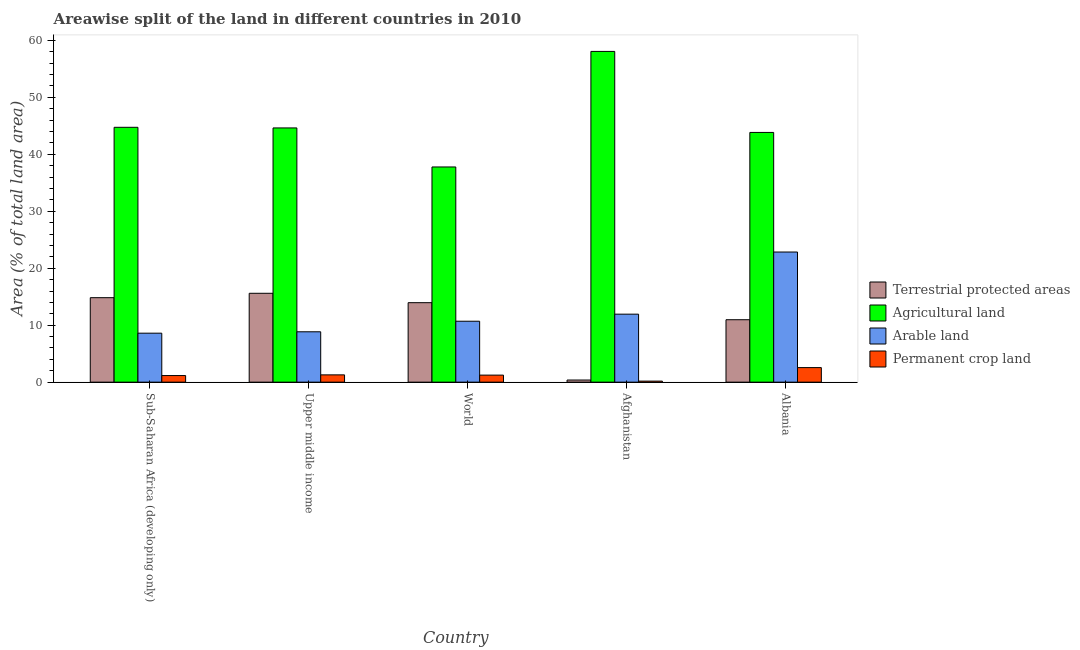How many different coloured bars are there?
Make the answer very short. 4. How many groups of bars are there?
Keep it short and to the point. 5. Are the number of bars on each tick of the X-axis equal?
Provide a succinct answer. Yes. How many bars are there on the 3rd tick from the left?
Provide a succinct answer. 4. What is the label of the 2nd group of bars from the left?
Provide a short and direct response. Upper middle income. In how many cases, is the number of bars for a given country not equal to the number of legend labels?
Provide a succinct answer. 0. What is the percentage of area under permanent crop land in World?
Offer a terse response. 1.23. Across all countries, what is the maximum percentage of area under agricultural land?
Give a very brief answer. 58.07. Across all countries, what is the minimum percentage of area under permanent crop land?
Your response must be concise. 0.18. In which country was the percentage of land under terrestrial protection maximum?
Your response must be concise. Upper middle income. In which country was the percentage of land under terrestrial protection minimum?
Offer a very short reply. Afghanistan. What is the total percentage of land under terrestrial protection in the graph?
Ensure brevity in your answer.  55.71. What is the difference between the percentage of land under terrestrial protection in Upper middle income and that in World?
Your answer should be very brief. 1.65. What is the difference between the percentage of area under permanent crop land in Sub-Saharan Africa (developing only) and the percentage of land under terrestrial protection in World?
Offer a terse response. -12.79. What is the average percentage of area under arable land per country?
Offer a terse response. 12.58. What is the difference between the percentage of area under permanent crop land and percentage of land under terrestrial protection in Afghanistan?
Keep it short and to the point. -0.19. What is the ratio of the percentage of area under arable land in Afghanistan to that in Upper middle income?
Make the answer very short. 1.35. What is the difference between the highest and the second highest percentage of land under terrestrial protection?
Make the answer very short. 0.77. What is the difference between the highest and the lowest percentage of land under terrestrial protection?
Offer a very short reply. 15.23. In how many countries, is the percentage of area under permanent crop land greater than the average percentage of area under permanent crop land taken over all countries?
Your answer should be very brief. 1. Is it the case that in every country, the sum of the percentage of area under permanent crop land and percentage of area under arable land is greater than the sum of percentage of area under agricultural land and percentage of land under terrestrial protection?
Make the answer very short. Yes. What does the 1st bar from the left in Afghanistan represents?
Provide a short and direct response. Terrestrial protected areas. What does the 4th bar from the right in Upper middle income represents?
Provide a short and direct response. Terrestrial protected areas. Is it the case that in every country, the sum of the percentage of land under terrestrial protection and percentage of area under agricultural land is greater than the percentage of area under arable land?
Provide a short and direct response. Yes. How many bars are there?
Ensure brevity in your answer.  20. How many countries are there in the graph?
Keep it short and to the point. 5. What is the difference between two consecutive major ticks on the Y-axis?
Provide a succinct answer. 10. Are the values on the major ticks of Y-axis written in scientific E-notation?
Provide a succinct answer. No. Does the graph contain grids?
Provide a short and direct response. No. How many legend labels are there?
Ensure brevity in your answer.  4. How are the legend labels stacked?
Ensure brevity in your answer.  Vertical. What is the title of the graph?
Provide a short and direct response. Areawise split of the land in different countries in 2010. What is the label or title of the X-axis?
Make the answer very short. Country. What is the label or title of the Y-axis?
Your answer should be very brief. Area (% of total land area). What is the Area (% of total land area) of Terrestrial protected areas in Sub-Saharan Africa (developing only)?
Make the answer very short. 14.83. What is the Area (% of total land area) in Agricultural land in Sub-Saharan Africa (developing only)?
Offer a very short reply. 44.74. What is the Area (% of total land area) of Arable land in Sub-Saharan Africa (developing only)?
Keep it short and to the point. 8.6. What is the Area (% of total land area) in Permanent crop land in Sub-Saharan Africa (developing only)?
Make the answer very short. 1.16. What is the Area (% of total land area) in Terrestrial protected areas in Upper middle income?
Provide a short and direct response. 15.6. What is the Area (% of total land area) in Agricultural land in Upper middle income?
Provide a short and direct response. 44.63. What is the Area (% of total land area) of Arable land in Upper middle income?
Your answer should be very brief. 8.84. What is the Area (% of total land area) in Permanent crop land in Upper middle income?
Ensure brevity in your answer.  1.28. What is the Area (% of total land area) of Terrestrial protected areas in World?
Ensure brevity in your answer.  13.95. What is the Area (% of total land area) of Agricultural land in World?
Your answer should be compact. 37.78. What is the Area (% of total land area) in Arable land in World?
Make the answer very short. 10.7. What is the Area (% of total land area) in Permanent crop land in World?
Ensure brevity in your answer.  1.23. What is the Area (% of total land area) in Terrestrial protected areas in Afghanistan?
Your answer should be very brief. 0.37. What is the Area (% of total land area) in Agricultural land in Afghanistan?
Offer a very short reply. 58.07. What is the Area (% of total land area) in Arable land in Afghanistan?
Make the answer very short. 11.94. What is the Area (% of total land area) in Permanent crop land in Afghanistan?
Your response must be concise. 0.18. What is the Area (% of total land area) of Terrestrial protected areas in Albania?
Your answer should be compact. 10.96. What is the Area (% of total land area) in Agricultural land in Albania?
Make the answer very short. 43.84. What is the Area (% of total land area) in Arable land in Albania?
Keep it short and to the point. 22.85. What is the Area (% of total land area) in Permanent crop land in Albania?
Ensure brevity in your answer.  2.55. Across all countries, what is the maximum Area (% of total land area) in Terrestrial protected areas?
Your answer should be compact. 15.6. Across all countries, what is the maximum Area (% of total land area) in Agricultural land?
Your answer should be compact. 58.07. Across all countries, what is the maximum Area (% of total land area) of Arable land?
Ensure brevity in your answer.  22.85. Across all countries, what is the maximum Area (% of total land area) of Permanent crop land?
Offer a terse response. 2.55. Across all countries, what is the minimum Area (% of total land area) of Terrestrial protected areas?
Offer a terse response. 0.37. Across all countries, what is the minimum Area (% of total land area) of Agricultural land?
Keep it short and to the point. 37.78. Across all countries, what is the minimum Area (% of total land area) in Arable land?
Give a very brief answer. 8.6. Across all countries, what is the minimum Area (% of total land area) of Permanent crop land?
Your answer should be compact. 0.18. What is the total Area (% of total land area) in Terrestrial protected areas in the graph?
Offer a very short reply. 55.71. What is the total Area (% of total land area) of Agricultural land in the graph?
Your response must be concise. 229.07. What is the total Area (% of total land area) of Arable land in the graph?
Your answer should be compact. 62.92. What is the total Area (% of total land area) of Permanent crop land in the graph?
Make the answer very short. 6.4. What is the difference between the Area (% of total land area) in Terrestrial protected areas in Sub-Saharan Africa (developing only) and that in Upper middle income?
Your answer should be very brief. -0.77. What is the difference between the Area (% of total land area) of Agricultural land in Sub-Saharan Africa (developing only) and that in Upper middle income?
Ensure brevity in your answer.  0.11. What is the difference between the Area (% of total land area) in Arable land in Sub-Saharan Africa (developing only) and that in Upper middle income?
Your answer should be very brief. -0.24. What is the difference between the Area (% of total land area) in Permanent crop land in Sub-Saharan Africa (developing only) and that in Upper middle income?
Give a very brief answer. -0.12. What is the difference between the Area (% of total land area) of Terrestrial protected areas in Sub-Saharan Africa (developing only) and that in World?
Give a very brief answer. 0.88. What is the difference between the Area (% of total land area) of Agricultural land in Sub-Saharan Africa (developing only) and that in World?
Keep it short and to the point. 6.96. What is the difference between the Area (% of total land area) of Arable land in Sub-Saharan Africa (developing only) and that in World?
Your answer should be compact. -2.1. What is the difference between the Area (% of total land area) in Permanent crop land in Sub-Saharan Africa (developing only) and that in World?
Your answer should be very brief. -0.08. What is the difference between the Area (% of total land area) in Terrestrial protected areas in Sub-Saharan Africa (developing only) and that in Afghanistan?
Keep it short and to the point. 14.46. What is the difference between the Area (% of total land area) in Agricultural land in Sub-Saharan Africa (developing only) and that in Afghanistan?
Give a very brief answer. -13.33. What is the difference between the Area (% of total land area) in Arable land in Sub-Saharan Africa (developing only) and that in Afghanistan?
Your answer should be compact. -3.34. What is the difference between the Area (% of total land area) in Permanent crop land in Sub-Saharan Africa (developing only) and that in Afghanistan?
Your answer should be compact. 0.98. What is the difference between the Area (% of total land area) of Terrestrial protected areas in Sub-Saharan Africa (developing only) and that in Albania?
Ensure brevity in your answer.  3.87. What is the difference between the Area (% of total land area) of Agricultural land in Sub-Saharan Africa (developing only) and that in Albania?
Make the answer very short. 0.9. What is the difference between the Area (% of total land area) of Arable land in Sub-Saharan Africa (developing only) and that in Albania?
Provide a short and direct response. -14.25. What is the difference between the Area (% of total land area) of Permanent crop land in Sub-Saharan Africa (developing only) and that in Albania?
Provide a succinct answer. -1.4. What is the difference between the Area (% of total land area) in Terrestrial protected areas in Upper middle income and that in World?
Your response must be concise. 1.65. What is the difference between the Area (% of total land area) in Agricultural land in Upper middle income and that in World?
Ensure brevity in your answer.  6.85. What is the difference between the Area (% of total land area) of Arable land in Upper middle income and that in World?
Give a very brief answer. -1.86. What is the difference between the Area (% of total land area) in Permanent crop land in Upper middle income and that in World?
Ensure brevity in your answer.  0.04. What is the difference between the Area (% of total land area) in Terrestrial protected areas in Upper middle income and that in Afghanistan?
Your answer should be very brief. 15.23. What is the difference between the Area (% of total land area) in Agricultural land in Upper middle income and that in Afghanistan?
Keep it short and to the point. -13.43. What is the difference between the Area (% of total land area) of Arable land in Upper middle income and that in Afghanistan?
Your response must be concise. -3.1. What is the difference between the Area (% of total land area) of Permanent crop land in Upper middle income and that in Afghanistan?
Make the answer very short. 1.1. What is the difference between the Area (% of total land area) of Terrestrial protected areas in Upper middle income and that in Albania?
Your answer should be compact. 4.64. What is the difference between the Area (% of total land area) of Agricultural land in Upper middle income and that in Albania?
Keep it short and to the point. 0.79. What is the difference between the Area (% of total land area) of Arable land in Upper middle income and that in Albania?
Offer a terse response. -14.01. What is the difference between the Area (% of total land area) of Permanent crop land in Upper middle income and that in Albania?
Keep it short and to the point. -1.28. What is the difference between the Area (% of total land area) in Terrestrial protected areas in World and that in Afghanistan?
Your answer should be compact. 13.58. What is the difference between the Area (% of total land area) in Agricultural land in World and that in Afghanistan?
Offer a terse response. -20.29. What is the difference between the Area (% of total land area) in Arable land in World and that in Afghanistan?
Provide a short and direct response. -1.24. What is the difference between the Area (% of total land area) in Permanent crop land in World and that in Afghanistan?
Your answer should be very brief. 1.05. What is the difference between the Area (% of total land area) of Terrestrial protected areas in World and that in Albania?
Make the answer very short. 2.99. What is the difference between the Area (% of total land area) of Agricultural land in World and that in Albania?
Offer a terse response. -6.06. What is the difference between the Area (% of total land area) in Arable land in World and that in Albania?
Provide a short and direct response. -12.15. What is the difference between the Area (% of total land area) of Permanent crop land in World and that in Albania?
Keep it short and to the point. -1.32. What is the difference between the Area (% of total land area) of Terrestrial protected areas in Afghanistan and that in Albania?
Ensure brevity in your answer.  -10.59. What is the difference between the Area (% of total land area) of Agricultural land in Afghanistan and that in Albania?
Offer a very short reply. 14.22. What is the difference between the Area (% of total land area) in Arable land in Afghanistan and that in Albania?
Your answer should be very brief. -10.91. What is the difference between the Area (% of total land area) of Permanent crop land in Afghanistan and that in Albania?
Your answer should be compact. -2.37. What is the difference between the Area (% of total land area) in Terrestrial protected areas in Sub-Saharan Africa (developing only) and the Area (% of total land area) in Agricultural land in Upper middle income?
Make the answer very short. -29.8. What is the difference between the Area (% of total land area) of Terrestrial protected areas in Sub-Saharan Africa (developing only) and the Area (% of total land area) of Arable land in Upper middle income?
Provide a succinct answer. 5.99. What is the difference between the Area (% of total land area) in Terrestrial protected areas in Sub-Saharan Africa (developing only) and the Area (% of total land area) in Permanent crop land in Upper middle income?
Your answer should be very brief. 13.55. What is the difference between the Area (% of total land area) in Agricultural land in Sub-Saharan Africa (developing only) and the Area (% of total land area) in Arable land in Upper middle income?
Your answer should be compact. 35.9. What is the difference between the Area (% of total land area) in Agricultural land in Sub-Saharan Africa (developing only) and the Area (% of total land area) in Permanent crop land in Upper middle income?
Ensure brevity in your answer.  43.46. What is the difference between the Area (% of total land area) of Arable land in Sub-Saharan Africa (developing only) and the Area (% of total land area) of Permanent crop land in Upper middle income?
Offer a terse response. 7.32. What is the difference between the Area (% of total land area) in Terrestrial protected areas in Sub-Saharan Africa (developing only) and the Area (% of total land area) in Agricultural land in World?
Keep it short and to the point. -22.95. What is the difference between the Area (% of total land area) in Terrestrial protected areas in Sub-Saharan Africa (developing only) and the Area (% of total land area) in Arable land in World?
Offer a very short reply. 4.13. What is the difference between the Area (% of total land area) of Terrestrial protected areas in Sub-Saharan Africa (developing only) and the Area (% of total land area) of Permanent crop land in World?
Your answer should be very brief. 13.6. What is the difference between the Area (% of total land area) in Agricultural land in Sub-Saharan Africa (developing only) and the Area (% of total land area) in Arable land in World?
Keep it short and to the point. 34.05. What is the difference between the Area (% of total land area) of Agricultural land in Sub-Saharan Africa (developing only) and the Area (% of total land area) of Permanent crop land in World?
Offer a terse response. 43.51. What is the difference between the Area (% of total land area) in Arable land in Sub-Saharan Africa (developing only) and the Area (% of total land area) in Permanent crop land in World?
Give a very brief answer. 7.36. What is the difference between the Area (% of total land area) of Terrestrial protected areas in Sub-Saharan Africa (developing only) and the Area (% of total land area) of Agricultural land in Afghanistan?
Your response must be concise. -43.24. What is the difference between the Area (% of total land area) of Terrestrial protected areas in Sub-Saharan Africa (developing only) and the Area (% of total land area) of Arable land in Afghanistan?
Provide a short and direct response. 2.89. What is the difference between the Area (% of total land area) in Terrestrial protected areas in Sub-Saharan Africa (developing only) and the Area (% of total land area) in Permanent crop land in Afghanistan?
Your response must be concise. 14.65. What is the difference between the Area (% of total land area) of Agricultural land in Sub-Saharan Africa (developing only) and the Area (% of total land area) of Arable land in Afghanistan?
Your response must be concise. 32.81. What is the difference between the Area (% of total land area) in Agricultural land in Sub-Saharan Africa (developing only) and the Area (% of total land area) in Permanent crop land in Afghanistan?
Offer a very short reply. 44.56. What is the difference between the Area (% of total land area) in Arable land in Sub-Saharan Africa (developing only) and the Area (% of total land area) in Permanent crop land in Afghanistan?
Give a very brief answer. 8.42. What is the difference between the Area (% of total land area) in Terrestrial protected areas in Sub-Saharan Africa (developing only) and the Area (% of total land area) in Agricultural land in Albania?
Offer a terse response. -29.01. What is the difference between the Area (% of total land area) of Terrestrial protected areas in Sub-Saharan Africa (developing only) and the Area (% of total land area) of Arable land in Albania?
Offer a terse response. -8.02. What is the difference between the Area (% of total land area) in Terrestrial protected areas in Sub-Saharan Africa (developing only) and the Area (% of total land area) in Permanent crop land in Albania?
Ensure brevity in your answer.  12.28. What is the difference between the Area (% of total land area) in Agricultural land in Sub-Saharan Africa (developing only) and the Area (% of total land area) in Arable land in Albania?
Keep it short and to the point. 21.9. What is the difference between the Area (% of total land area) of Agricultural land in Sub-Saharan Africa (developing only) and the Area (% of total land area) of Permanent crop land in Albania?
Provide a short and direct response. 42.19. What is the difference between the Area (% of total land area) in Arable land in Sub-Saharan Africa (developing only) and the Area (% of total land area) in Permanent crop land in Albania?
Your response must be concise. 6.04. What is the difference between the Area (% of total land area) in Terrestrial protected areas in Upper middle income and the Area (% of total land area) in Agricultural land in World?
Keep it short and to the point. -22.18. What is the difference between the Area (% of total land area) in Terrestrial protected areas in Upper middle income and the Area (% of total land area) in Arable land in World?
Provide a succinct answer. 4.9. What is the difference between the Area (% of total land area) in Terrestrial protected areas in Upper middle income and the Area (% of total land area) in Permanent crop land in World?
Your answer should be very brief. 14.37. What is the difference between the Area (% of total land area) of Agricultural land in Upper middle income and the Area (% of total land area) of Arable land in World?
Your response must be concise. 33.94. What is the difference between the Area (% of total land area) of Agricultural land in Upper middle income and the Area (% of total land area) of Permanent crop land in World?
Your response must be concise. 43.4. What is the difference between the Area (% of total land area) in Arable land in Upper middle income and the Area (% of total land area) in Permanent crop land in World?
Offer a very short reply. 7.61. What is the difference between the Area (% of total land area) of Terrestrial protected areas in Upper middle income and the Area (% of total land area) of Agricultural land in Afghanistan?
Your answer should be very brief. -42.47. What is the difference between the Area (% of total land area) in Terrestrial protected areas in Upper middle income and the Area (% of total land area) in Arable land in Afghanistan?
Give a very brief answer. 3.66. What is the difference between the Area (% of total land area) in Terrestrial protected areas in Upper middle income and the Area (% of total land area) in Permanent crop land in Afghanistan?
Give a very brief answer. 15.42. What is the difference between the Area (% of total land area) of Agricultural land in Upper middle income and the Area (% of total land area) of Arable land in Afghanistan?
Make the answer very short. 32.7. What is the difference between the Area (% of total land area) of Agricultural land in Upper middle income and the Area (% of total land area) of Permanent crop land in Afghanistan?
Make the answer very short. 44.45. What is the difference between the Area (% of total land area) in Arable land in Upper middle income and the Area (% of total land area) in Permanent crop land in Afghanistan?
Provide a short and direct response. 8.66. What is the difference between the Area (% of total land area) of Terrestrial protected areas in Upper middle income and the Area (% of total land area) of Agricultural land in Albania?
Provide a short and direct response. -28.24. What is the difference between the Area (% of total land area) in Terrestrial protected areas in Upper middle income and the Area (% of total land area) in Arable land in Albania?
Your answer should be compact. -7.25. What is the difference between the Area (% of total land area) of Terrestrial protected areas in Upper middle income and the Area (% of total land area) of Permanent crop land in Albania?
Give a very brief answer. 13.05. What is the difference between the Area (% of total land area) of Agricultural land in Upper middle income and the Area (% of total land area) of Arable land in Albania?
Make the answer very short. 21.79. What is the difference between the Area (% of total land area) of Agricultural land in Upper middle income and the Area (% of total land area) of Permanent crop land in Albania?
Your response must be concise. 42.08. What is the difference between the Area (% of total land area) of Arable land in Upper middle income and the Area (% of total land area) of Permanent crop land in Albania?
Provide a succinct answer. 6.29. What is the difference between the Area (% of total land area) in Terrestrial protected areas in World and the Area (% of total land area) in Agricultural land in Afghanistan?
Keep it short and to the point. -44.12. What is the difference between the Area (% of total land area) in Terrestrial protected areas in World and the Area (% of total land area) in Arable land in Afghanistan?
Provide a short and direct response. 2.01. What is the difference between the Area (% of total land area) in Terrestrial protected areas in World and the Area (% of total land area) in Permanent crop land in Afghanistan?
Give a very brief answer. 13.77. What is the difference between the Area (% of total land area) in Agricultural land in World and the Area (% of total land area) in Arable land in Afghanistan?
Ensure brevity in your answer.  25.84. What is the difference between the Area (% of total land area) in Agricultural land in World and the Area (% of total land area) in Permanent crop land in Afghanistan?
Ensure brevity in your answer.  37.6. What is the difference between the Area (% of total land area) of Arable land in World and the Area (% of total land area) of Permanent crop land in Afghanistan?
Ensure brevity in your answer.  10.52. What is the difference between the Area (% of total land area) of Terrestrial protected areas in World and the Area (% of total land area) of Agricultural land in Albania?
Offer a terse response. -29.89. What is the difference between the Area (% of total land area) in Terrestrial protected areas in World and the Area (% of total land area) in Arable land in Albania?
Make the answer very short. -8.9. What is the difference between the Area (% of total land area) of Terrestrial protected areas in World and the Area (% of total land area) of Permanent crop land in Albania?
Make the answer very short. 11.4. What is the difference between the Area (% of total land area) of Agricultural land in World and the Area (% of total land area) of Arable land in Albania?
Ensure brevity in your answer.  14.93. What is the difference between the Area (% of total land area) of Agricultural land in World and the Area (% of total land area) of Permanent crop land in Albania?
Offer a very short reply. 35.22. What is the difference between the Area (% of total land area) of Arable land in World and the Area (% of total land area) of Permanent crop land in Albania?
Provide a short and direct response. 8.14. What is the difference between the Area (% of total land area) of Terrestrial protected areas in Afghanistan and the Area (% of total land area) of Agricultural land in Albania?
Give a very brief answer. -43.47. What is the difference between the Area (% of total land area) in Terrestrial protected areas in Afghanistan and the Area (% of total land area) in Arable land in Albania?
Offer a terse response. -22.47. What is the difference between the Area (% of total land area) of Terrestrial protected areas in Afghanistan and the Area (% of total land area) of Permanent crop land in Albania?
Your answer should be compact. -2.18. What is the difference between the Area (% of total land area) in Agricultural land in Afghanistan and the Area (% of total land area) in Arable land in Albania?
Keep it short and to the point. 35.22. What is the difference between the Area (% of total land area) in Agricultural land in Afghanistan and the Area (% of total land area) in Permanent crop land in Albania?
Offer a very short reply. 55.51. What is the difference between the Area (% of total land area) in Arable land in Afghanistan and the Area (% of total land area) in Permanent crop land in Albania?
Provide a succinct answer. 9.38. What is the average Area (% of total land area) in Terrestrial protected areas per country?
Your answer should be very brief. 11.14. What is the average Area (% of total land area) of Agricultural land per country?
Ensure brevity in your answer.  45.81. What is the average Area (% of total land area) in Arable land per country?
Make the answer very short. 12.58. What is the average Area (% of total land area) of Permanent crop land per country?
Provide a succinct answer. 1.28. What is the difference between the Area (% of total land area) of Terrestrial protected areas and Area (% of total land area) of Agricultural land in Sub-Saharan Africa (developing only)?
Your answer should be very brief. -29.91. What is the difference between the Area (% of total land area) of Terrestrial protected areas and Area (% of total land area) of Arable land in Sub-Saharan Africa (developing only)?
Keep it short and to the point. 6.23. What is the difference between the Area (% of total land area) of Terrestrial protected areas and Area (% of total land area) of Permanent crop land in Sub-Saharan Africa (developing only)?
Offer a terse response. 13.67. What is the difference between the Area (% of total land area) of Agricultural land and Area (% of total land area) of Arable land in Sub-Saharan Africa (developing only)?
Your answer should be compact. 36.14. What is the difference between the Area (% of total land area) in Agricultural land and Area (% of total land area) in Permanent crop land in Sub-Saharan Africa (developing only)?
Give a very brief answer. 43.58. What is the difference between the Area (% of total land area) of Arable land and Area (% of total land area) of Permanent crop land in Sub-Saharan Africa (developing only)?
Offer a terse response. 7.44. What is the difference between the Area (% of total land area) of Terrestrial protected areas and Area (% of total land area) of Agricultural land in Upper middle income?
Your answer should be very brief. -29.03. What is the difference between the Area (% of total land area) of Terrestrial protected areas and Area (% of total land area) of Arable land in Upper middle income?
Make the answer very short. 6.76. What is the difference between the Area (% of total land area) in Terrestrial protected areas and Area (% of total land area) in Permanent crop land in Upper middle income?
Give a very brief answer. 14.32. What is the difference between the Area (% of total land area) in Agricultural land and Area (% of total land area) in Arable land in Upper middle income?
Make the answer very short. 35.79. What is the difference between the Area (% of total land area) of Agricultural land and Area (% of total land area) of Permanent crop land in Upper middle income?
Offer a terse response. 43.36. What is the difference between the Area (% of total land area) of Arable land and Area (% of total land area) of Permanent crop land in Upper middle income?
Your answer should be very brief. 7.56. What is the difference between the Area (% of total land area) in Terrestrial protected areas and Area (% of total land area) in Agricultural land in World?
Your answer should be compact. -23.83. What is the difference between the Area (% of total land area) in Terrestrial protected areas and Area (% of total land area) in Arable land in World?
Make the answer very short. 3.25. What is the difference between the Area (% of total land area) in Terrestrial protected areas and Area (% of total land area) in Permanent crop land in World?
Make the answer very short. 12.72. What is the difference between the Area (% of total land area) in Agricultural land and Area (% of total land area) in Arable land in World?
Your answer should be compact. 27.08. What is the difference between the Area (% of total land area) of Agricultural land and Area (% of total land area) of Permanent crop land in World?
Your answer should be compact. 36.55. What is the difference between the Area (% of total land area) in Arable land and Area (% of total land area) in Permanent crop land in World?
Your answer should be very brief. 9.46. What is the difference between the Area (% of total land area) of Terrestrial protected areas and Area (% of total land area) of Agricultural land in Afghanistan?
Offer a terse response. -57.7. What is the difference between the Area (% of total land area) in Terrestrial protected areas and Area (% of total land area) in Arable land in Afghanistan?
Ensure brevity in your answer.  -11.56. What is the difference between the Area (% of total land area) of Terrestrial protected areas and Area (% of total land area) of Permanent crop land in Afghanistan?
Give a very brief answer. 0.19. What is the difference between the Area (% of total land area) in Agricultural land and Area (% of total land area) in Arable land in Afghanistan?
Your response must be concise. 46.13. What is the difference between the Area (% of total land area) in Agricultural land and Area (% of total land area) in Permanent crop land in Afghanistan?
Your answer should be very brief. 57.89. What is the difference between the Area (% of total land area) in Arable land and Area (% of total land area) in Permanent crop land in Afghanistan?
Offer a terse response. 11.76. What is the difference between the Area (% of total land area) in Terrestrial protected areas and Area (% of total land area) in Agricultural land in Albania?
Your answer should be compact. -32.88. What is the difference between the Area (% of total land area) of Terrestrial protected areas and Area (% of total land area) of Arable land in Albania?
Make the answer very short. -11.89. What is the difference between the Area (% of total land area) of Terrestrial protected areas and Area (% of total land area) of Permanent crop land in Albania?
Your response must be concise. 8.41. What is the difference between the Area (% of total land area) of Agricultural land and Area (% of total land area) of Arable land in Albania?
Provide a succinct answer. 21. What is the difference between the Area (% of total land area) in Agricultural land and Area (% of total land area) in Permanent crop land in Albania?
Offer a terse response. 41.29. What is the difference between the Area (% of total land area) of Arable land and Area (% of total land area) of Permanent crop land in Albania?
Your answer should be very brief. 20.29. What is the ratio of the Area (% of total land area) in Terrestrial protected areas in Sub-Saharan Africa (developing only) to that in Upper middle income?
Your answer should be compact. 0.95. What is the ratio of the Area (% of total land area) of Agricultural land in Sub-Saharan Africa (developing only) to that in Upper middle income?
Give a very brief answer. 1. What is the ratio of the Area (% of total land area) in Arable land in Sub-Saharan Africa (developing only) to that in Upper middle income?
Make the answer very short. 0.97. What is the ratio of the Area (% of total land area) in Permanent crop land in Sub-Saharan Africa (developing only) to that in Upper middle income?
Your response must be concise. 0.91. What is the ratio of the Area (% of total land area) in Terrestrial protected areas in Sub-Saharan Africa (developing only) to that in World?
Keep it short and to the point. 1.06. What is the ratio of the Area (% of total land area) in Agricultural land in Sub-Saharan Africa (developing only) to that in World?
Keep it short and to the point. 1.18. What is the ratio of the Area (% of total land area) of Arable land in Sub-Saharan Africa (developing only) to that in World?
Provide a short and direct response. 0.8. What is the ratio of the Area (% of total land area) in Permanent crop land in Sub-Saharan Africa (developing only) to that in World?
Your answer should be compact. 0.94. What is the ratio of the Area (% of total land area) of Terrestrial protected areas in Sub-Saharan Africa (developing only) to that in Afghanistan?
Ensure brevity in your answer.  39.87. What is the ratio of the Area (% of total land area) in Agricultural land in Sub-Saharan Africa (developing only) to that in Afghanistan?
Provide a short and direct response. 0.77. What is the ratio of the Area (% of total land area) of Arable land in Sub-Saharan Africa (developing only) to that in Afghanistan?
Offer a terse response. 0.72. What is the ratio of the Area (% of total land area) of Permanent crop land in Sub-Saharan Africa (developing only) to that in Afghanistan?
Your response must be concise. 6.4. What is the ratio of the Area (% of total land area) in Terrestrial protected areas in Sub-Saharan Africa (developing only) to that in Albania?
Provide a short and direct response. 1.35. What is the ratio of the Area (% of total land area) in Agricultural land in Sub-Saharan Africa (developing only) to that in Albania?
Keep it short and to the point. 1.02. What is the ratio of the Area (% of total land area) in Arable land in Sub-Saharan Africa (developing only) to that in Albania?
Provide a succinct answer. 0.38. What is the ratio of the Area (% of total land area) of Permanent crop land in Sub-Saharan Africa (developing only) to that in Albania?
Keep it short and to the point. 0.45. What is the ratio of the Area (% of total land area) in Terrestrial protected areas in Upper middle income to that in World?
Your answer should be compact. 1.12. What is the ratio of the Area (% of total land area) of Agricultural land in Upper middle income to that in World?
Offer a terse response. 1.18. What is the ratio of the Area (% of total land area) in Arable land in Upper middle income to that in World?
Your answer should be very brief. 0.83. What is the ratio of the Area (% of total land area) of Permanent crop land in Upper middle income to that in World?
Provide a short and direct response. 1.04. What is the ratio of the Area (% of total land area) in Terrestrial protected areas in Upper middle income to that in Afghanistan?
Offer a very short reply. 41.93. What is the ratio of the Area (% of total land area) in Agricultural land in Upper middle income to that in Afghanistan?
Offer a terse response. 0.77. What is the ratio of the Area (% of total land area) of Arable land in Upper middle income to that in Afghanistan?
Your response must be concise. 0.74. What is the ratio of the Area (% of total land area) of Permanent crop land in Upper middle income to that in Afghanistan?
Offer a terse response. 7.07. What is the ratio of the Area (% of total land area) of Terrestrial protected areas in Upper middle income to that in Albania?
Your answer should be very brief. 1.42. What is the ratio of the Area (% of total land area) in Arable land in Upper middle income to that in Albania?
Offer a very short reply. 0.39. What is the ratio of the Area (% of total land area) in Permanent crop land in Upper middle income to that in Albania?
Offer a terse response. 0.5. What is the ratio of the Area (% of total land area) in Terrestrial protected areas in World to that in Afghanistan?
Your response must be concise. 37.5. What is the ratio of the Area (% of total land area) in Agricultural land in World to that in Afghanistan?
Your answer should be very brief. 0.65. What is the ratio of the Area (% of total land area) in Arable land in World to that in Afghanistan?
Your answer should be very brief. 0.9. What is the ratio of the Area (% of total land area) in Permanent crop land in World to that in Afghanistan?
Keep it short and to the point. 6.82. What is the ratio of the Area (% of total land area) in Terrestrial protected areas in World to that in Albania?
Offer a terse response. 1.27. What is the ratio of the Area (% of total land area) of Agricultural land in World to that in Albania?
Keep it short and to the point. 0.86. What is the ratio of the Area (% of total land area) in Arable land in World to that in Albania?
Make the answer very short. 0.47. What is the ratio of the Area (% of total land area) of Permanent crop land in World to that in Albania?
Make the answer very short. 0.48. What is the ratio of the Area (% of total land area) in Terrestrial protected areas in Afghanistan to that in Albania?
Keep it short and to the point. 0.03. What is the ratio of the Area (% of total land area) of Agricultural land in Afghanistan to that in Albania?
Make the answer very short. 1.32. What is the ratio of the Area (% of total land area) in Arable land in Afghanistan to that in Albania?
Your response must be concise. 0.52. What is the ratio of the Area (% of total land area) in Permanent crop land in Afghanistan to that in Albania?
Offer a terse response. 0.07. What is the difference between the highest and the second highest Area (% of total land area) of Terrestrial protected areas?
Offer a very short reply. 0.77. What is the difference between the highest and the second highest Area (% of total land area) of Agricultural land?
Give a very brief answer. 13.33. What is the difference between the highest and the second highest Area (% of total land area) of Arable land?
Your response must be concise. 10.91. What is the difference between the highest and the second highest Area (% of total land area) in Permanent crop land?
Keep it short and to the point. 1.28. What is the difference between the highest and the lowest Area (% of total land area) of Terrestrial protected areas?
Give a very brief answer. 15.23. What is the difference between the highest and the lowest Area (% of total land area) of Agricultural land?
Your answer should be compact. 20.29. What is the difference between the highest and the lowest Area (% of total land area) in Arable land?
Ensure brevity in your answer.  14.25. What is the difference between the highest and the lowest Area (% of total land area) of Permanent crop land?
Provide a short and direct response. 2.37. 